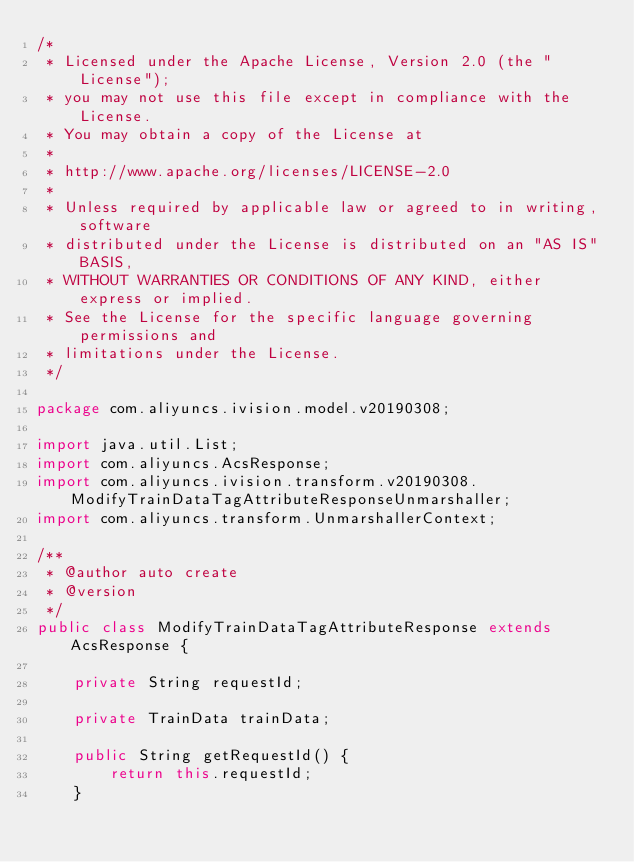<code> <loc_0><loc_0><loc_500><loc_500><_Java_>/*
 * Licensed under the Apache License, Version 2.0 (the "License");
 * you may not use this file except in compliance with the License.
 * You may obtain a copy of the License at
 *
 * http://www.apache.org/licenses/LICENSE-2.0
 *
 * Unless required by applicable law or agreed to in writing, software
 * distributed under the License is distributed on an "AS IS" BASIS,
 * WITHOUT WARRANTIES OR CONDITIONS OF ANY KIND, either express or implied.
 * See the License for the specific language governing permissions and
 * limitations under the License.
 */

package com.aliyuncs.ivision.model.v20190308;

import java.util.List;
import com.aliyuncs.AcsResponse;
import com.aliyuncs.ivision.transform.v20190308.ModifyTrainDataTagAttributeResponseUnmarshaller;
import com.aliyuncs.transform.UnmarshallerContext;

/**
 * @author auto create
 * @version 
 */
public class ModifyTrainDataTagAttributeResponse extends AcsResponse {

	private String requestId;

	private TrainData trainData;

	public String getRequestId() {
		return this.requestId;
	}</code> 